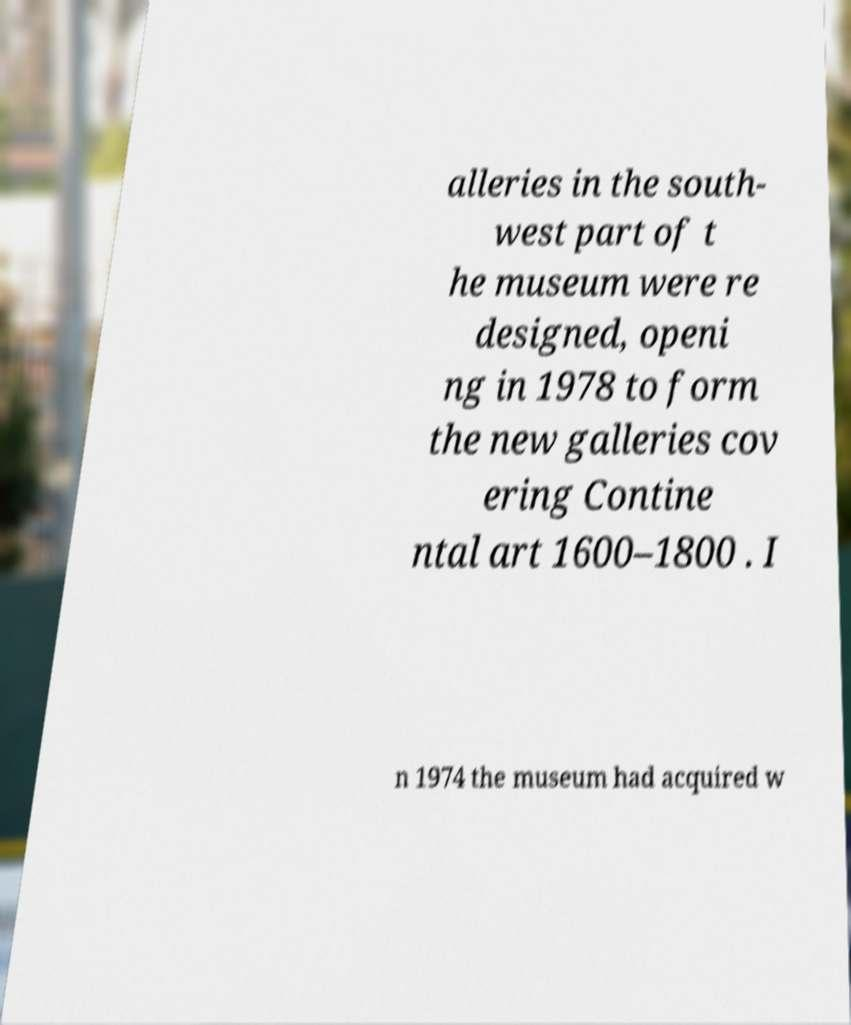Please read and relay the text visible in this image. What does it say? alleries in the south- west part of t he museum were re designed, openi ng in 1978 to form the new galleries cov ering Contine ntal art 1600–1800 . I n 1974 the museum had acquired w 